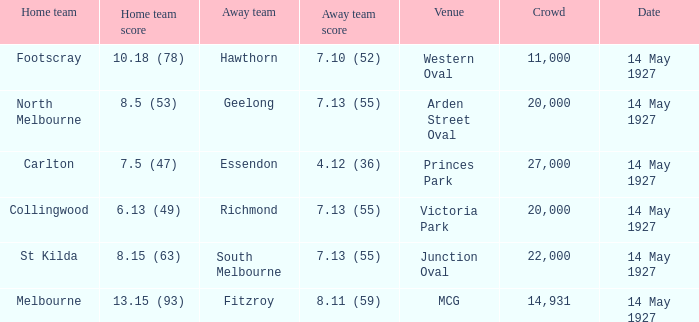Which venue hosted a home team with a score of 13.15 (93)? MCG. 